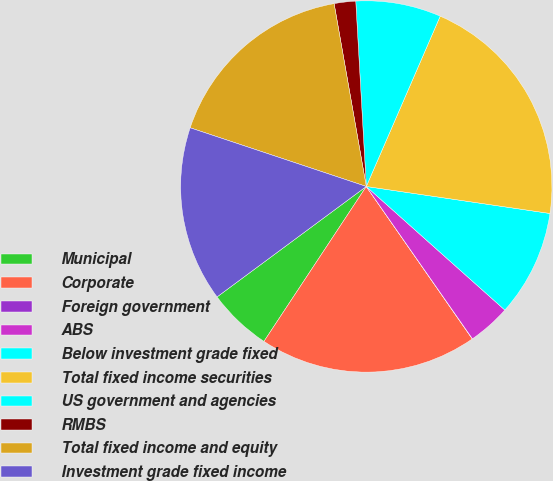Convert chart. <chart><loc_0><loc_0><loc_500><loc_500><pie_chart><fcel>Municipal<fcel>Corporate<fcel>Foreign government<fcel>ABS<fcel>Below investment grade fixed<fcel>Total fixed income securities<fcel>US government and agencies<fcel>RMBS<fcel>Total fixed income and equity<fcel>Investment grade fixed income<nl><fcel>5.57%<fcel>18.96%<fcel>0.02%<fcel>3.72%<fcel>9.27%<fcel>20.81%<fcel>7.42%<fcel>1.87%<fcel>17.11%<fcel>15.26%<nl></chart> 